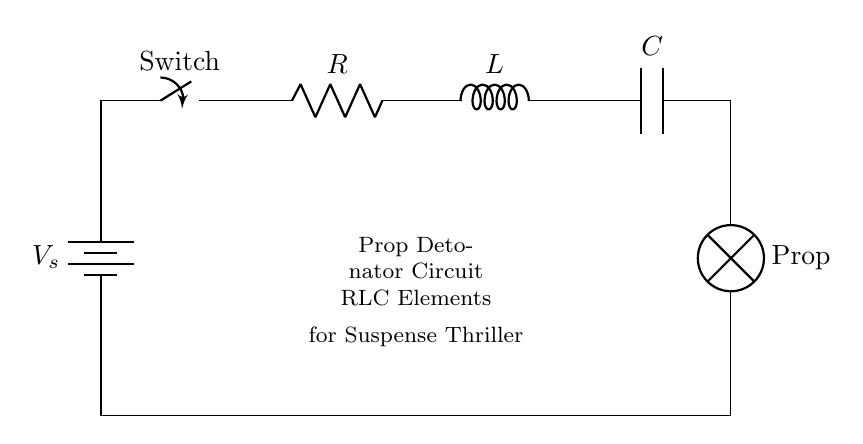What is the power source in this circuit? The power source is a battery, as indicated by the "V_s" label in the circuit diagram.
Answer: battery What components make up this circuit? The circuit is made up of a resistor, inductor, capacitor, and a lamp. These components can be identified by their respective labels (R, L, C, and lamp) in the diagram.
Answer: resistor, inductor, capacitor, lamp What does the switch control in this circuit? The switch controls the on or off state of the circuit, allowing or disallowing current to flow through the components. This can be inferred from the position of the switch in the diagram, interrupting the circuit path when open.
Answer: current flow What is the purpose of the capacitor in this circuit? The capacitor is used to store electrical energy and release it at a controlled rate, which is vital for timing and phase control in an RLC circuit, especially in applications such as a detonator where precise timing can be critical.
Answer: timing How do the RLC elements affect circuit behavior? The resistor, inductor, and capacitor together determine the circuit's impedance and resonance frequency, defining how the circuit responds to alternating currents, which is crucial for achieving the desired activation timing in an explosive scenario. This relationship is fundamental to understanding RLC circuits.
Answer: impedance and resonance What occurs when the switch is closed? Closing the switch completes the circuit, allowing current to flow from the battery through the resistor, inductor, capacitor, and lamp. This initiates the operation of the circuit and can also lead to potential energy release through the lamp, activating the prop detonator.
Answer: activates the circuit 